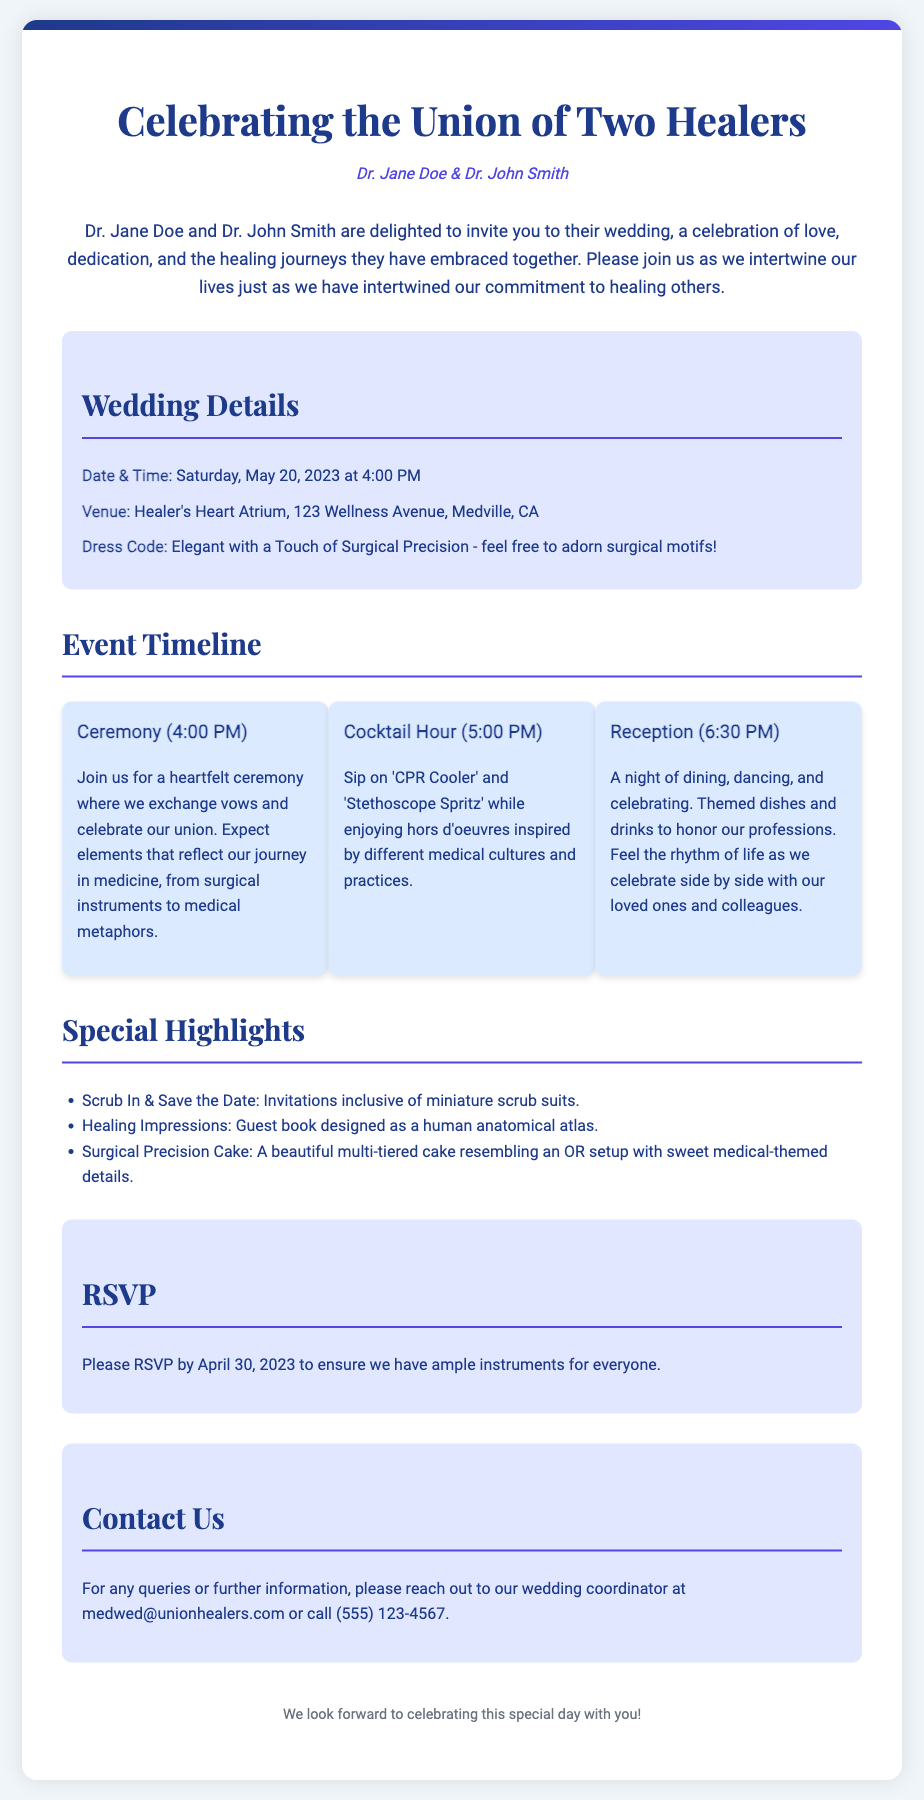what are the names of the couple getting married? The names of the couple are clearly highlighted at the top of the invitation.
Answer: Dr. Jane Doe & Dr. John Smith what is the date of the wedding? The wedding date is specified in the details section of the document.
Answer: Saturday, May 20, 2023 what time does the ceremony start? The ceremony time is provided under the event timeline section.
Answer: 4:00 PM where is the wedding venue? The venue information is included in the wedding details section.
Answer: Healer's Heart Atrium, 123 Wellness Avenue, Medville, CA what is the dress code for the wedding? The dress code is outlined in the wedding details section as well.
Answer: Elegant with a Touch of Surgical Precision what type of drinks will be served during the cocktail hour? The drinks are mentioned in the timeline for the cocktail hour.
Answer: 'CPR Cooler' and 'Stethoscope Spritz' how should guests RSVP? The RSVP instructions are noted in the RSVP section of the document.
Answer: RSVP by April 30, 2023 what unique guest book is being used at the wedding? The guest book information is included under special highlights.
Answer: human anatomical atlas what is the theme of the wedding cake? The theme of the cake is described in the special highlights section.
Answer: surgical precision 